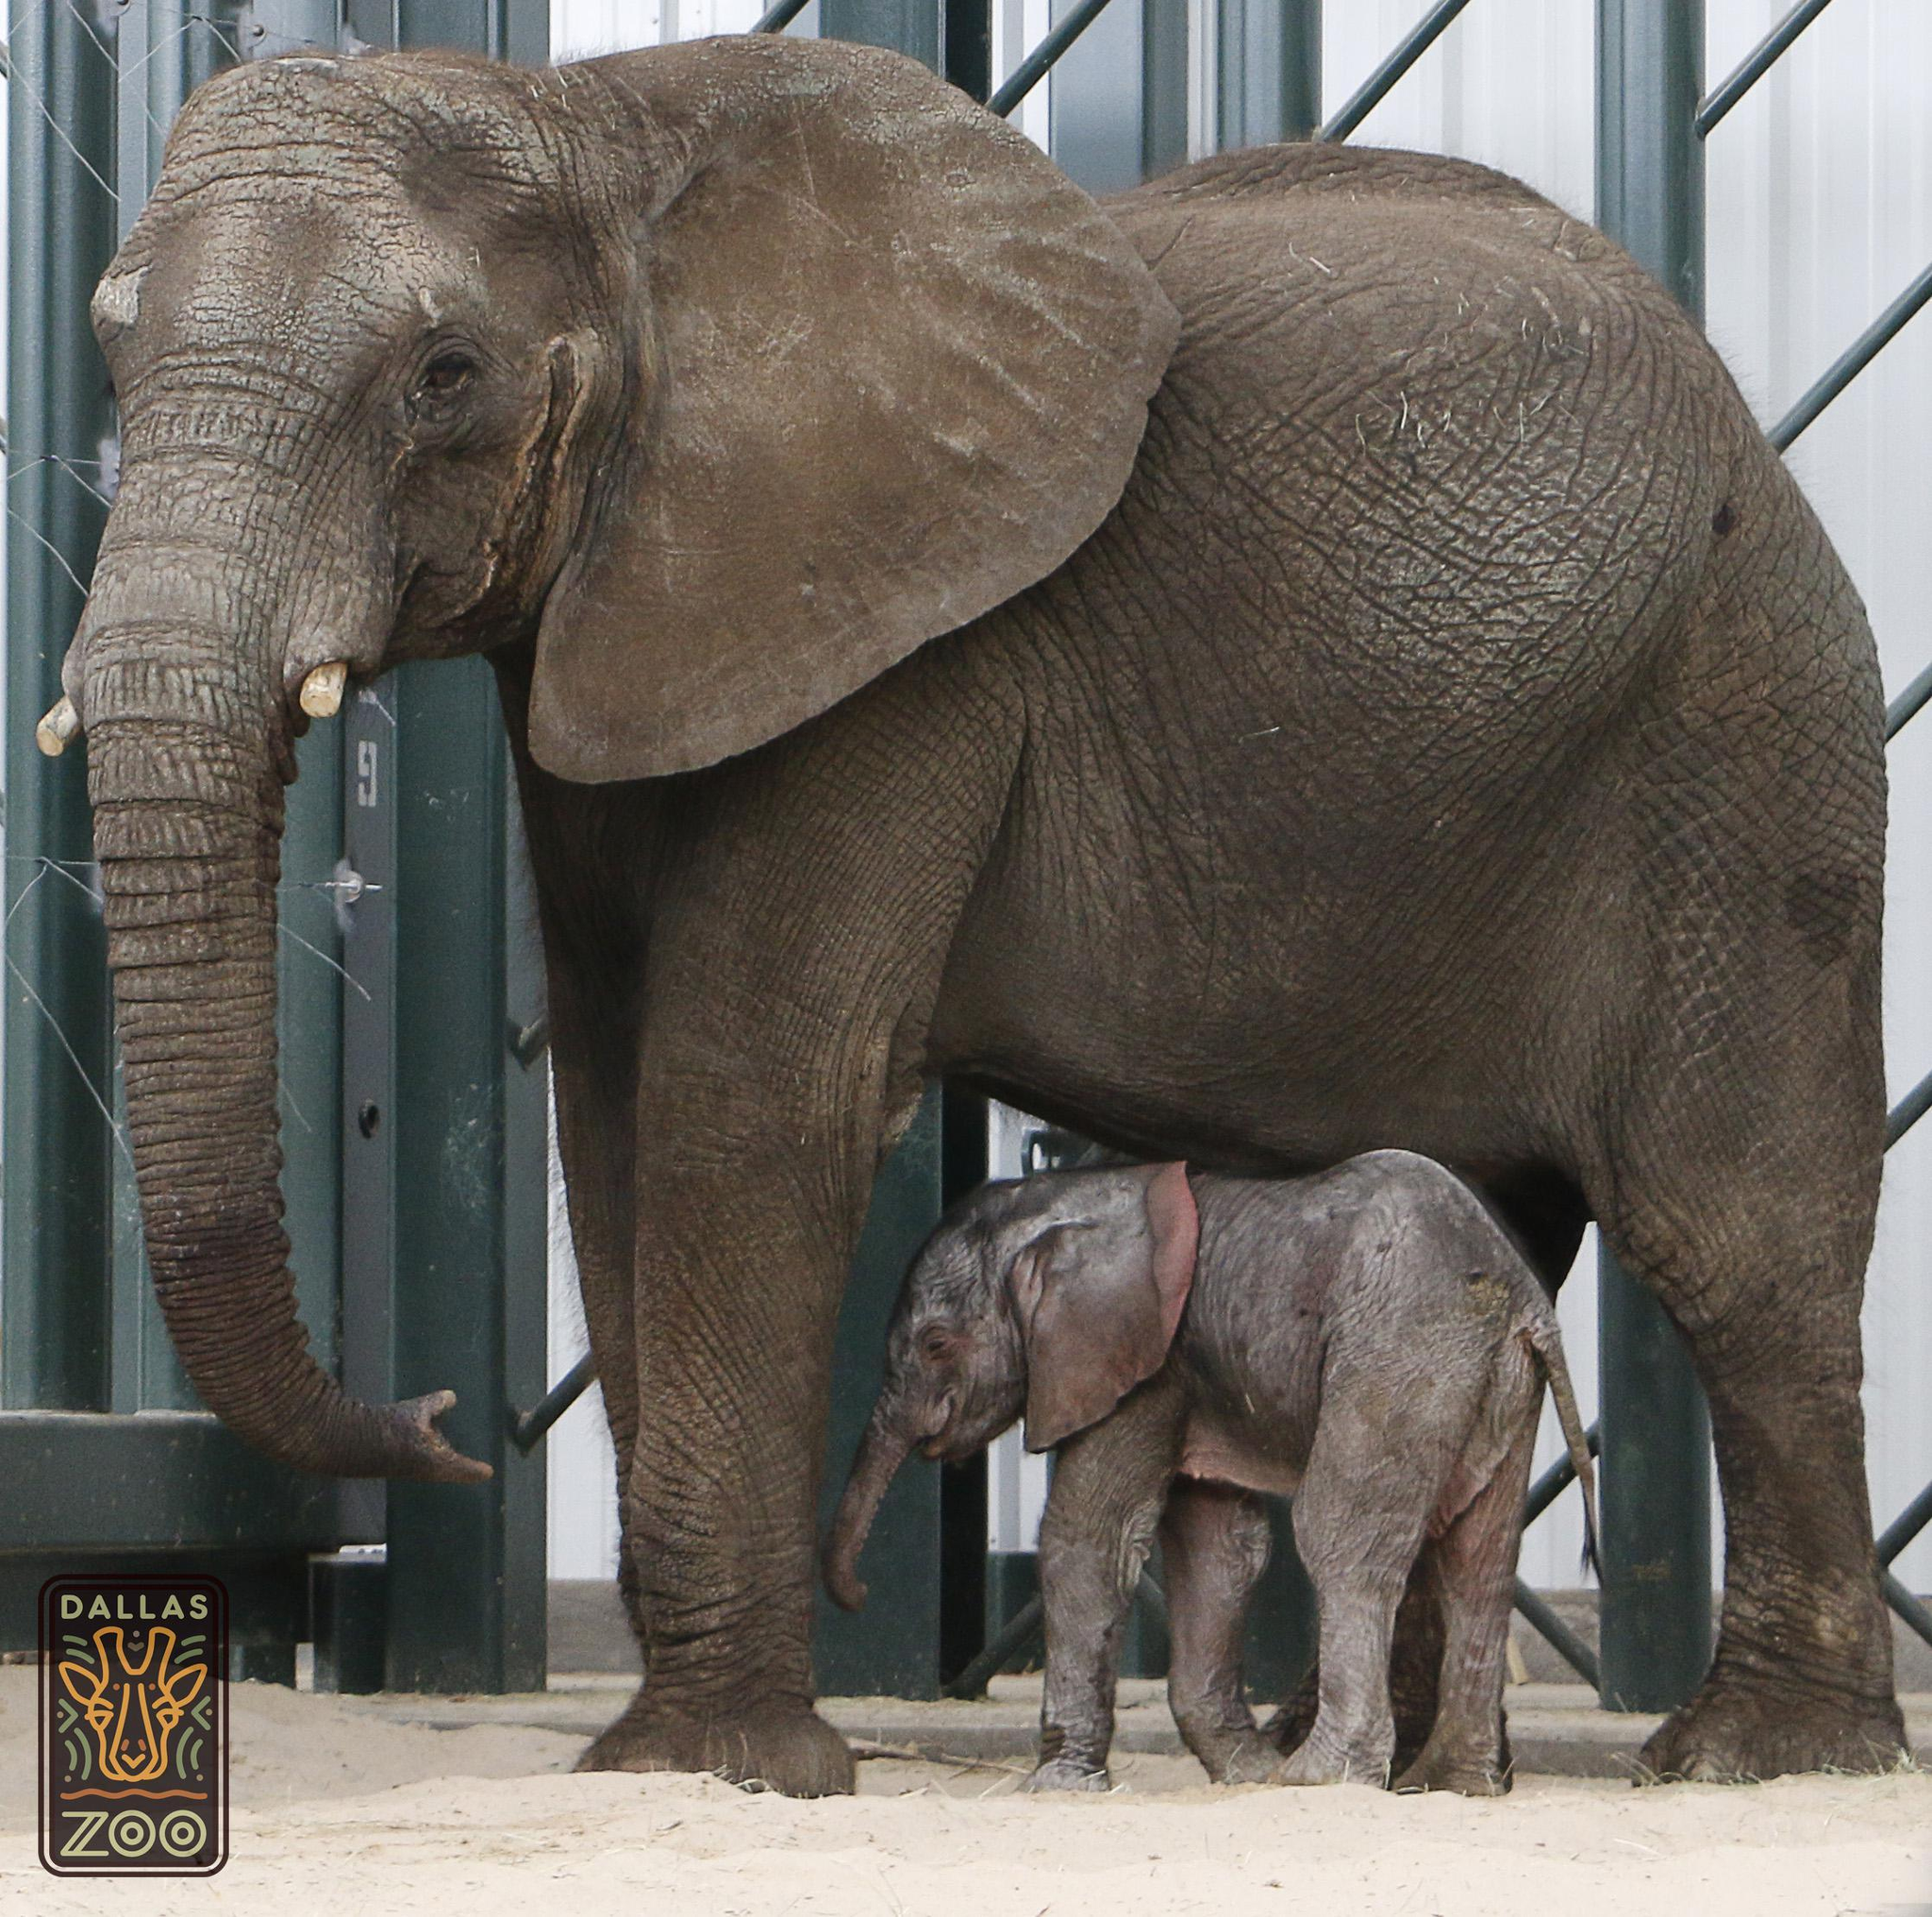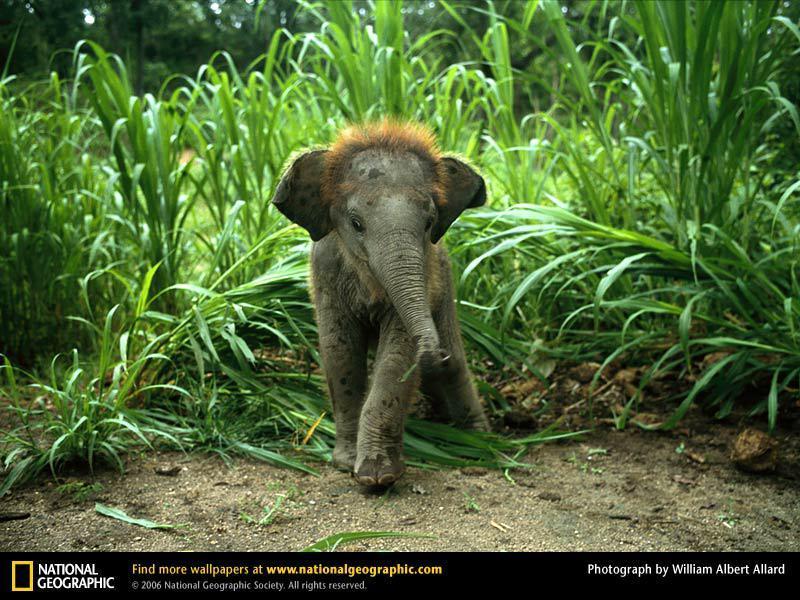The first image is the image on the left, the second image is the image on the right. Analyze the images presented: Is the assertion "There is 1 small elephant climbing on something." valid? Answer yes or no. No. The first image is the image on the left, the second image is the image on the right. Given the left and right images, does the statement "One of the images shows only one elephant." hold true? Answer yes or no. Yes. The first image is the image on the left, the second image is the image on the right. For the images displayed, is the sentence "there are two elephants in the image on the right" factually correct? Answer yes or no. No. The first image is the image on the left, the second image is the image on the right. Analyze the images presented: Is the assertion "A mother and baby elephant are actively engaged together in a natural setting." valid? Answer yes or no. No. 